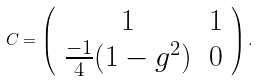<formula> <loc_0><loc_0><loc_500><loc_500>C = \left ( \begin{array} { c c } 1 & 1 \\ \frac { - 1 } { 4 } ( 1 - g ^ { 2 } ) & 0 \end{array} \right ) .</formula> 